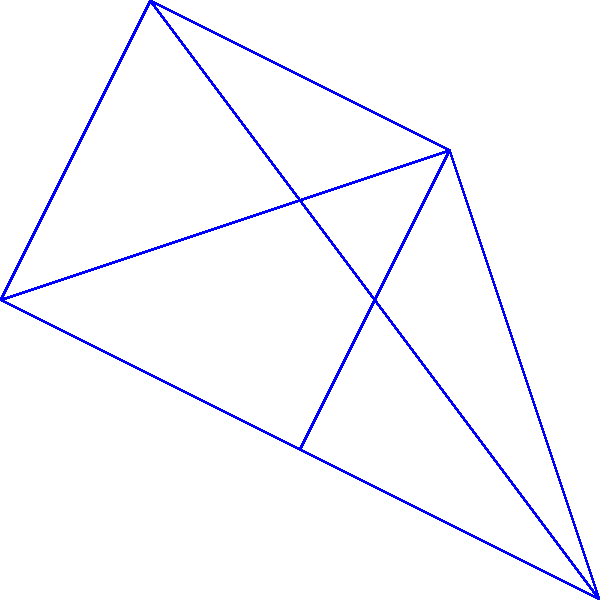You're setting up a home theater in your lanai and need to connect electrical outlets represented by the vertices in the graph. The edges represent potential wiring paths, and the numbers on the edges indicate the length of wire (in feet) needed for each connection. What's the minimum total length of wire needed to connect all outlets, ensuring every outlet is accessible? To find the minimum total length of wire needed to connect all outlets, we need to find the Minimum Spanning Tree (MST) of the given graph. We can use Kruskal's algorithm to solve this problem:

1. Sort all edges by weight (length) in ascending order:
   $(v_2, v_3): 1$, $(v_1, v_2): 2$, $(v_3, v_4): 2$, $(v_0, v_1): 3$, $(v_2, v_4): 3$, $(v_0, v_3): 4$, $(v_0, v_2): 5$, $(v_1, v_4): 6$

2. Start with an empty set of edges and add edges one by one, ensuring no cycles are formed:
   - Add $(v_2, v_3): 1$
   - Add $(v_1, v_2): 2$
   - Add $(v_3, v_4): 2$
   - Add $(v_0, v_1): 3$

3. At this point, all vertices are connected, and we have the Minimum Spanning Tree.

4. Sum up the weights of the selected edges:
   $1 + 2 + 2 + 3 = 8$

Therefore, the minimum total length of wire needed to connect all outlets is 8 feet.
Answer: 8 feet 